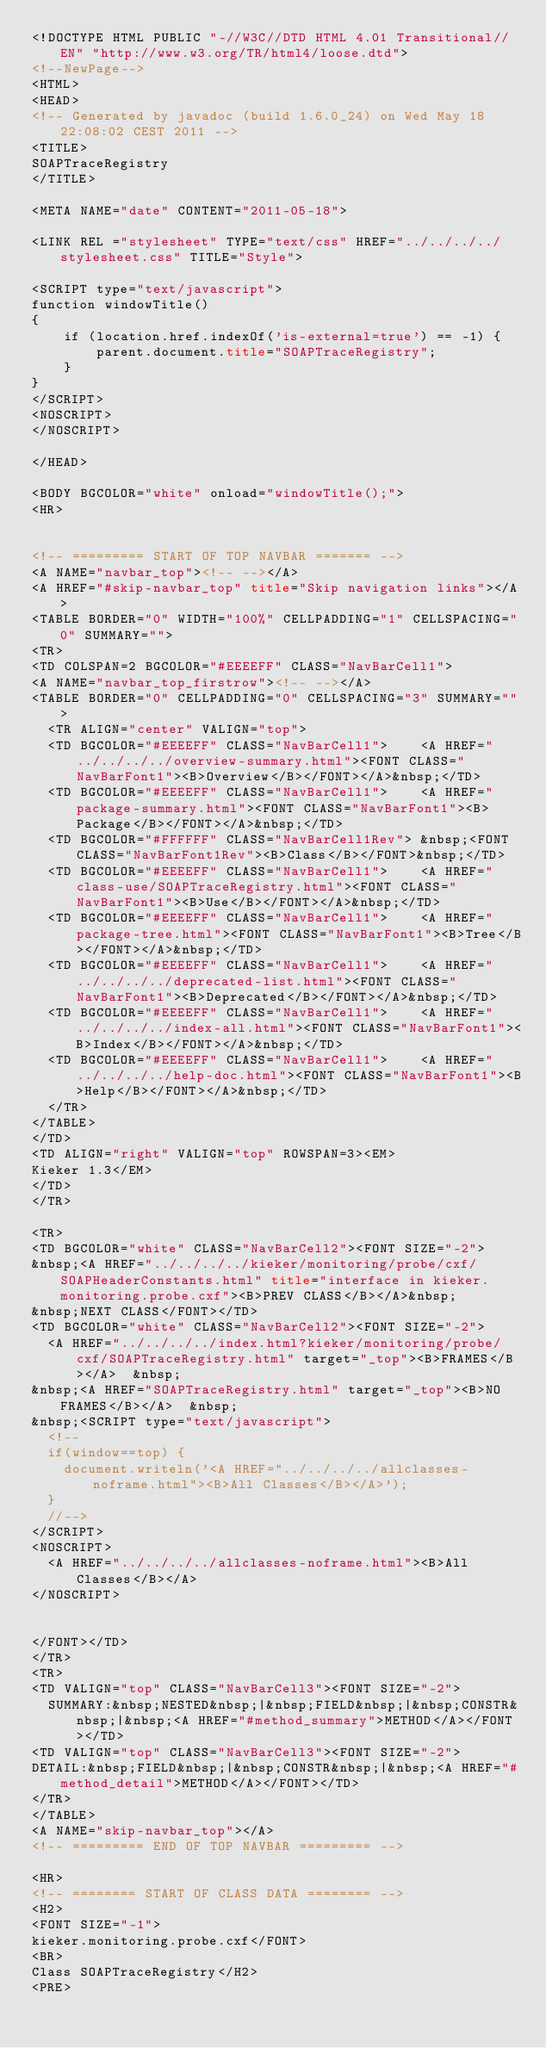Convert code to text. <code><loc_0><loc_0><loc_500><loc_500><_HTML_><!DOCTYPE HTML PUBLIC "-//W3C//DTD HTML 4.01 Transitional//EN" "http://www.w3.org/TR/html4/loose.dtd">
<!--NewPage-->
<HTML>
<HEAD>
<!-- Generated by javadoc (build 1.6.0_24) on Wed May 18 22:08:02 CEST 2011 -->
<TITLE>
SOAPTraceRegistry
</TITLE>

<META NAME="date" CONTENT="2011-05-18">

<LINK REL ="stylesheet" TYPE="text/css" HREF="../../../../stylesheet.css" TITLE="Style">

<SCRIPT type="text/javascript">
function windowTitle()
{
    if (location.href.indexOf('is-external=true') == -1) {
        parent.document.title="SOAPTraceRegistry";
    }
}
</SCRIPT>
<NOSCRIPT>
</NOSCRIPT>

</HEAD>

<BODY BGCOLOR="white" onload="windowTitle();">
<HR>


<!-- ========= START OF TOP NAVBAR ======= -->
<A NAME="navbar_top"><!-- --></A>
<A HREF="#skip-navbar_top" title="Skip navigation links"></A>
<TABLE BORDER="0" WIDTH="100%" CELLPADDING="1" CELLSPACING="0" SUMMARY="">
<TR>
<TD COLSPAN=2 BGCOLOR="#EEEEFF" CLASS="NavBarCell1">
<A NAME="navbar_top_firstrow"><!-- --></A>
<TABLE BORDER="0" CELLPADDING="0" CELLSPACING="3" SUMMARY="">
  <TR ALIGN="center" VALIGN="top">
  <TD BGCOLOR="#EEEEFF" CLASS="NavBarCell1">    <A HREF="../../../../overview-summary.html"><FONT CLASS="NavBarFont1"><B>Overview</B></FONT></A>&nbsp;</TD>
  <TD BGCOLOR="#EEEEFF" CLASS="NavBarCell1">    <A HREF="package-summary.html"><FONT CLASS="NavBarFont1"><B>Package</B></FONT></A>&nbsp;</TD>
  <TD BGCOLOR="#FFFFFF" CLASS="NavBarCell1Rev"> &nbsp;<FONT CLASS="NavBarFont1Rev"><B>Class</B></FONT>&nbsp;</TD>
  <TD BGCOLOR="#EEEEFF" CLASS="NavBarCell1">    <A HREF="class-use/SOAPTraceRegistry.html"><FONT CLASS="NavBarFont1"><B>Use</B></FONT></A>&nbsp;</TD>
  <TD BGCOLOR="#EEEEFF" CLASS="NavBarCell1">    <A HREF="package-tree.html"><FONT CLASS="NavBarFont1"><B>Tree</B></FONT></A>&nbsp;</TD>
  <TD BGCOLOR="#EEEEFF" CLASS="NavBarCell1">    <A HREF="../../../../deprecated-list.html"><FONT CLASS="NavBarFont1"><B>Deprecated</B></FONT></A>&nbsp;</TD>
  <TD BGCOLOR="#EEEEFF" CLASS="NavBarCell1">    <A HREF="../../../../index-all.html"><FONT CLASS="NavBarFont1"><B>Index</B></FONT></A>&nbsp;</TD>
  <TD BGCOLOR="#EEEEFF" CLASS="NavBarCell1">    <A HREF="../../../../help-doc.html"><FONT CLASS="NavBarFont1"><B>Help</B></FONT></A>&nbsp;</TD>
  </TR>
</TABLE>
</TD>
<TD ALIGN="right" VALIGN="top" ROWSPAN=3><EM>
Kieker 1.3</EM>
</TD>
</TR>

<TR>
<TD BGCOLOR="white" CLASS="NavBarCell2"><FONT SIZE="-2">
&nbsp;<A HREF="../../../../kieker/monitoring/probe/cxf/SOAPHeaderConstants.html" title="interface in kieker.monitoring.probe.cxf"><B>PREV CLASS</B></A>&nbsp;
&nbsp;NEXT CLASS</FONT></TD>
<TD BGCOLOR="white" CLASS="NavBarCell2"><FONT SIZE="-2">
  <A HREF="../../../../index.html?kieker/monitoring/probe/cxf/SOAPTraceRegistry.html" target="_top"><B>FRAMES</B></A>  &nbsp;
&nbsp;<A HREF="SOAPTraceRegistry.html" target="_top"><B>NO FRAMES</B></A>  &nbsp;
&nbsp;<SCRIPT type="text/javascript">
  <!--
  if(window==top) {
    document.writeln('<A HREF="../../../../allclasses-noframe.html"><B>All Classes</B></A>');
  }
  //-->
</SCRIPT>
<NOSCRIPT>
  <A HREF="../../../../allclasses-noframe.html"><B>All Classes</B></A>
</NOSCRIPT>


</FONT></TD>
</TR>
<TR>
<TD VALIGN="top" CLASS="NavBarCell3"><FONT SIZE="-2">
  SUMMARY:&nbsp;NESTED&nbsp;|&nbsp;FIELD&nbsp;|&nbsp;CONSTR&nbsp;|&nbsp;<A HREF="#method_summary">METHOD</A></FONT></TD>
<TD VALIGN="top" CLASS="NavBarCell3"><FONT SIZE="-2">
DETAIL:&nbsp;FIELD&nbsp;|&nbsp;CONSTR&nbsp;|&nbsp;<A HREF="#method_detail">METHOD</A></FONT></TD>
</TR>
</TABLE>
<A NAME="skip-navbar_top"></A>
<!-- ========= END OF TOP NAVBAR ========= -->

<HR>
<!-- ======== START OF CLASS DATA ======== -->
<H2>
<FONT SIZE="-1">
kieker.monitoring.probe.cxf</FONT>
<BR>
Class SOAPTraceRegistry</H2>
<PRE></code> 